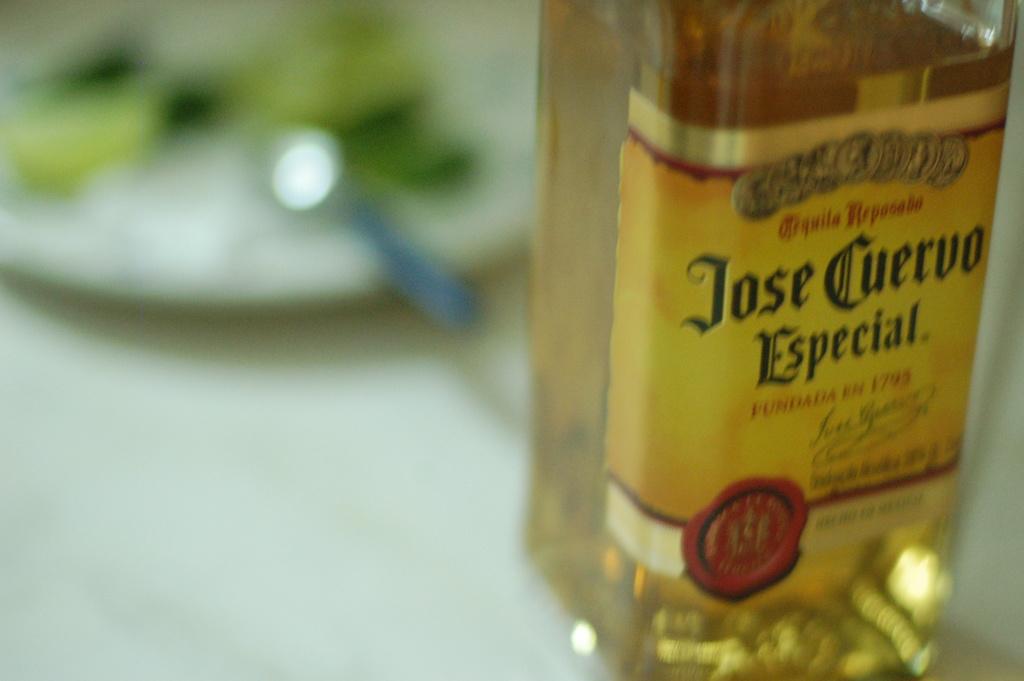What brand of tequila is this?
Your answer should be compact. Jose cuervo. What year is on the bottle?
Offer a terse response. 1795. 